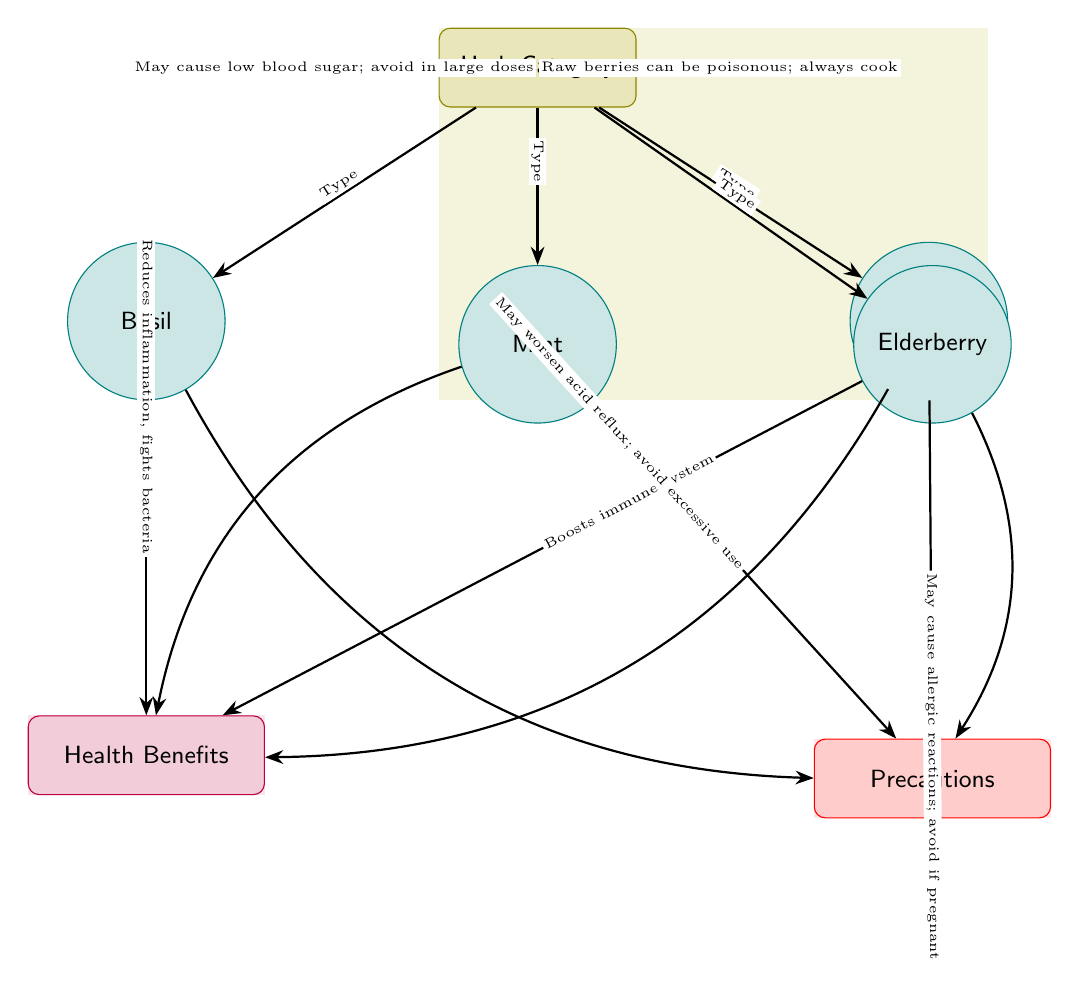What herbs are listed in the diagram? The diagram features four herbs: Basil, Mint, Chamomile, and Elderberry.
Answer: Basil, Mint, Chamomile, Elderberry What health benefit is associated with Chamomile? The diagram specifies that Chamomile improves sleep and reduces anxiety, focusing on its calming effects.
Answer: Improves sleep, reduces anxiety How many precautions are mentioned for Mint? The diagram lists one precaution for Mint, which indicates that it may worsen acid reflux and should be avoided in excessive use.
Answer: One What is the relationship between Basil and its health benefits? The diagram shows an edge connecting Basil to the health benefits node, noting that it reduces inflammation and fights bacteria.
Answer: Reduces inflammation, fights bacteria What may happen if you consume raw Elderberry berries? According to the diagram, consuming raw Elderberry berries can be poisonous, thus it's necessary to cook them before consumption.
Answer: Can be poisonous; always cook Which herb may cause allergic reactions? The diagram identifies Chamomile as potentially causing allergic reactions, particularly warning against its use if pregnant.
Answer: Chamomile How many nodes represent herbs in the diagram? The diagram clearly displays four nodes that each represent a distinct herb category, namely Basil, Mint, Chamomile, and Elderberry.
Answer: Four What is the main precaution related to Basil? The diagram advises that Basil may cause low blood sugar, especially indicating a need to avoid it in large doses to escape complications.
Answer: May cause low blood sugar; avoid in large doses Which herb aids digestion and eases breathing? The diagram directly associates Mint with aiding digestion and easing breathing, highlighting its medicinal properties.
Answer: Mint 